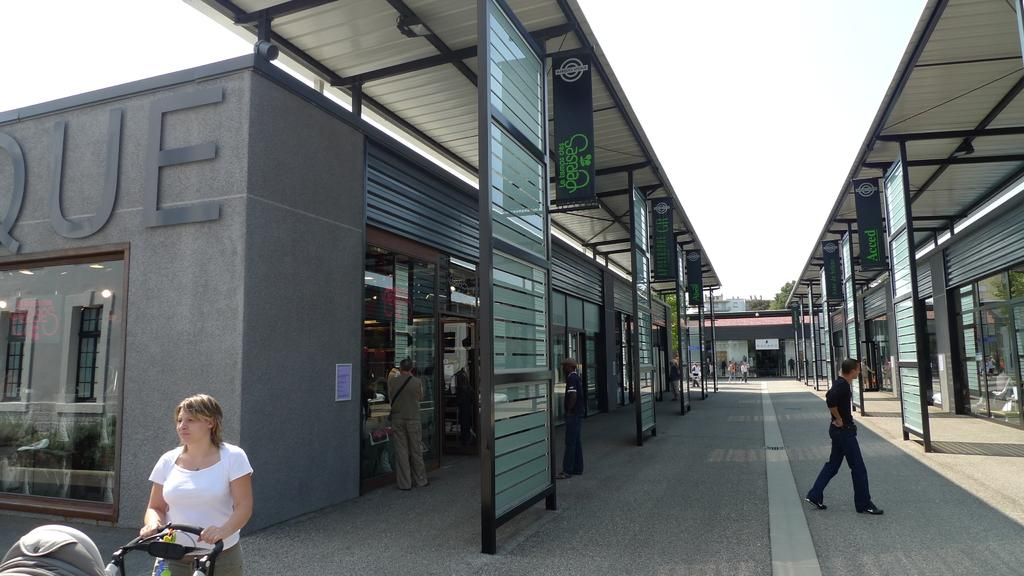How many people are in the group visible in the image? There is a group of people standing in the image, but the exact number cannot be determined from the provided facts. What is the person holding in the image? The person is holding a stroller in the image. What type of structures can be seen in the image? There are houses in the image. What other objects are present in the image? There are boards and trees in the image. What is visible in the background of the image? The sky is visible in the background of the image. What color is the knee of the person holding the bubble in the image? There is no person holding a bubble in the image, and therefore no knee or color to describe. 